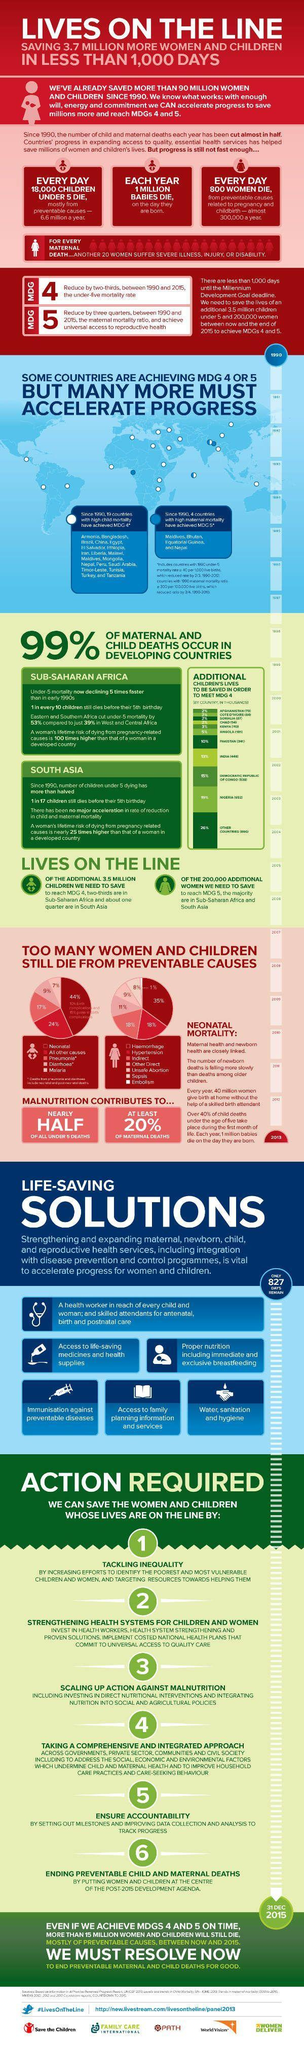What is the name of the program which is meant for women and maternal health?
Answer the question with a short phrase. MDG 5 What is the inverse percentage of death of pregnant women and new born babies in developing countries? 1 What percentage of Maternal Deaths are not due to Malnutrition? 80 How many women are dying each year due to maternity and childbirth related issues? 800 What percentage of Women and Child death are due to malaria and Diarrhoea? 16 How many days of Life Saving Solutions have been completed? 173 What percentage of Women and Child death are due to Sepsis and Unsafe Abortion? 17 How many days are left for the Life Saving Mission to end? 827 What is the death rate of children under 5 in South Asia? 1 in 17 In a year how many new born babies are dying on the same day they born? 1 milion 